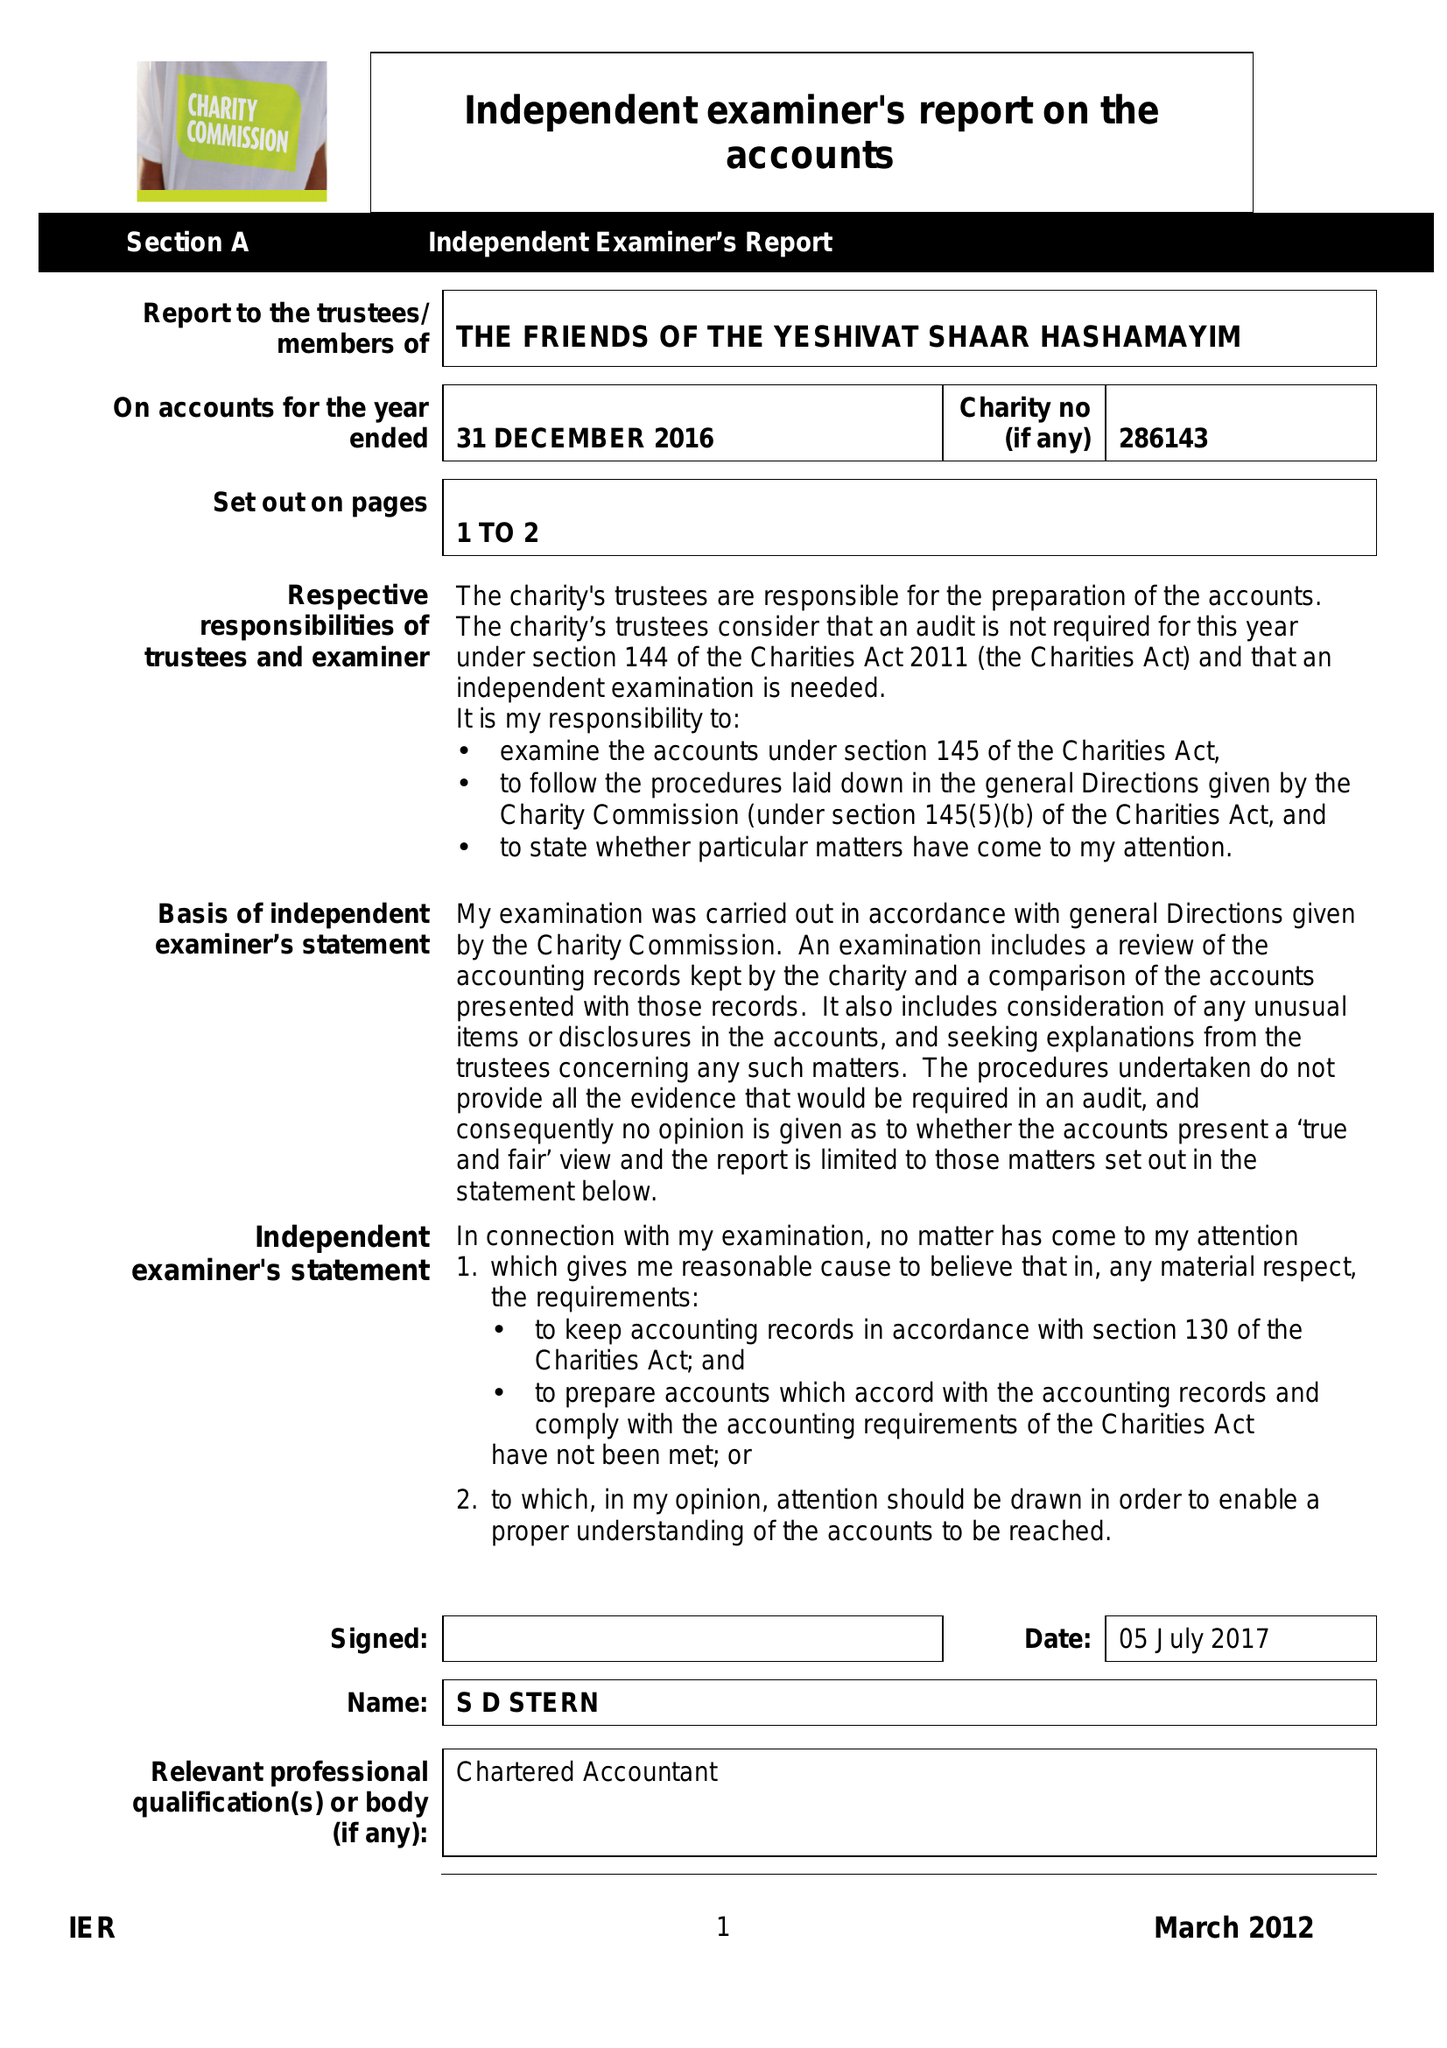What is the value for the address__postcode?
Answer the question using a single word or phrase. NW11 8AA 